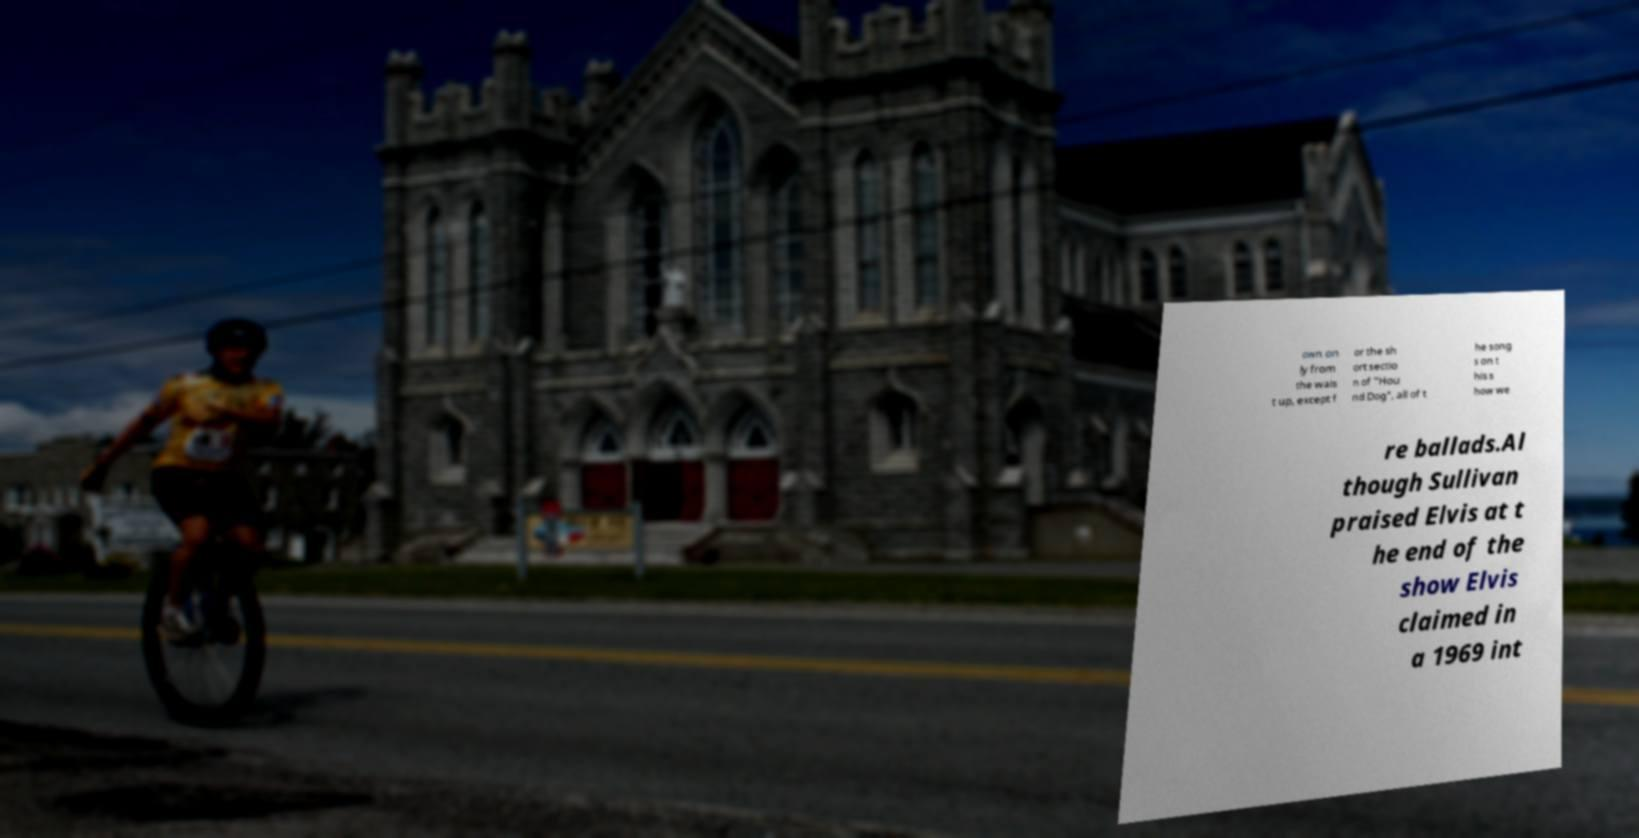Can you read and provide the text displayed in the image?This photo seems to have some interesting text. Can you extract and type it out for me? own on ly from the wais t up, except f or the sh ort sectio n of "Hou nd Dog", all of t he song s on t his s how we re ballads.Al though Sullivan praised Elvis at t he end of the show Elvis claimed in a 1969 int 